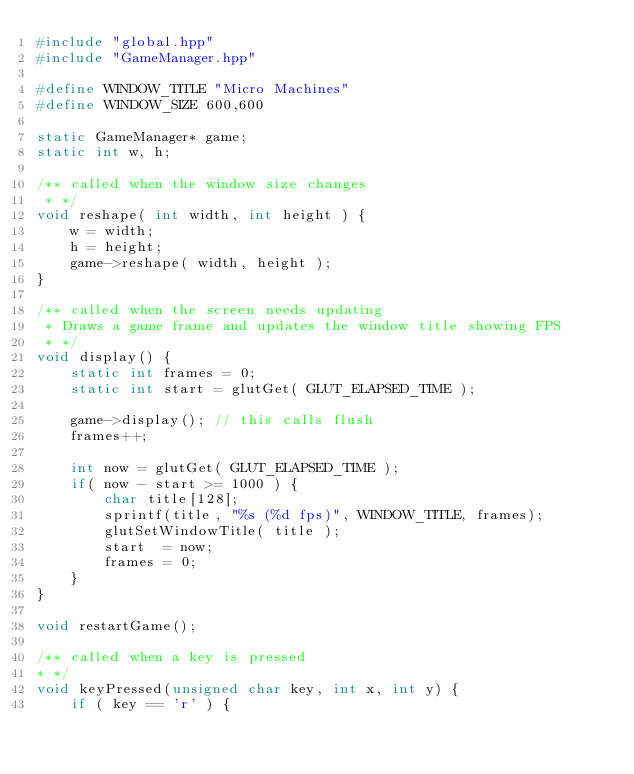Convert code to text. <code><loc_0><loc_0><loc_500><loc_500><_C++_>#include "global.hpp"
#include "GameManager.hpp"

#define WINDOW_TITLE "Micro Machines"
#define WINDOW_SIZE 600,600

static GameManager* game;
static int w, h;

/** called when the window size changes
 * */
void reshape( int width, int height ) {
    w = width;
    h = height;
    game->reshape( width, height );
}

/** called when the screen needs updating
 * Draws a game frame and updates the window title showing FPS
 * */
void display() {
    static int frames = 0;
    static int start = glutGet( GLUT_ELAPSED_TIME );

    game->display(); // this calls flush
    frames++;

    int now = glutGet( GLUT_ELAPSED_TIME );
    if( now - start >= 1000 ) {
        char title[128];
        sprintf(title, "%s (%d fps)", WINDOW_TITLE, frames);
        glutSetWindowTitle( title );
        start  = now;
        frames = 0;
    }
}

void restartGame();

/** called when a key is pressed
* */
void keyPressed(unsigned char key, int x, int y) {
    if ( key == 'r' ) {</code> 